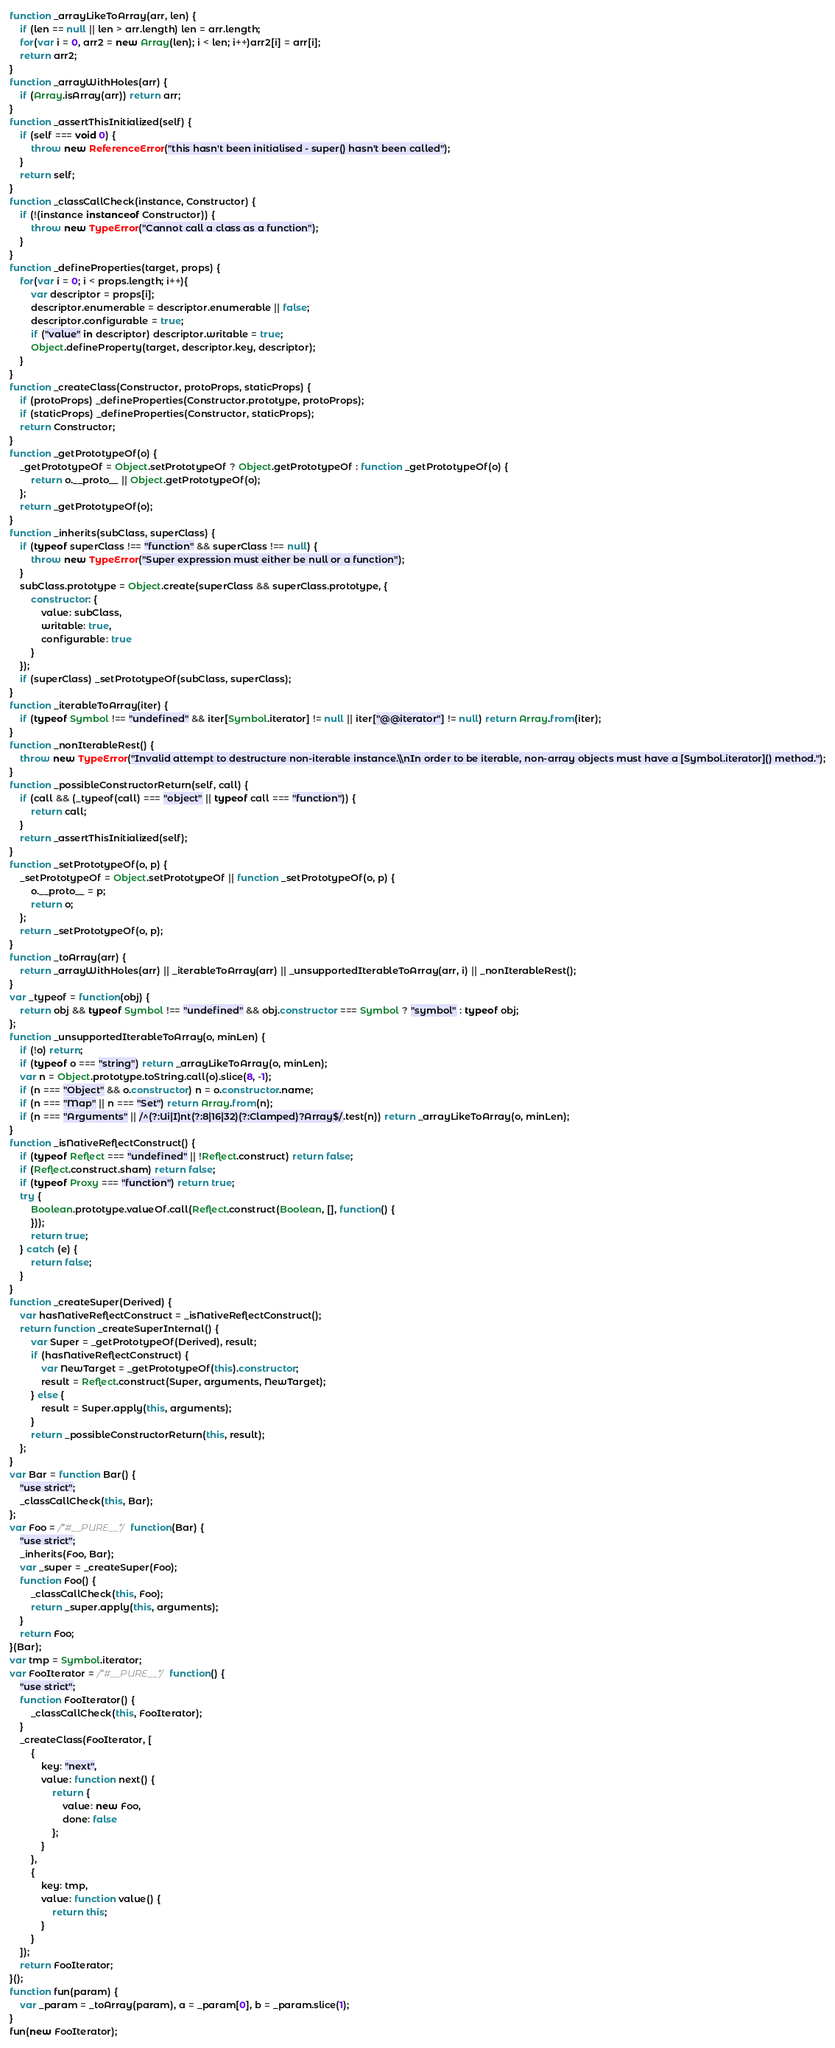Convert code to text. <code><loc_0><loc_0><loc_500><loc_500><_JavaScript_>function _arrayLikeToArray(arr, len) {
    if (len == null || len > arr.length) len = arr.length;
    for(var i = 0, arr2 = new Array(len); i < len; i++)arr2[i] = arr[i];
    return arr2;
}
function _arrayWithHoles(arr) {
    if (Array.isArray(arr)) return arr;
}
function _assertThisInitialized(self) {
    if (self === void 0) {
        throw new ReferenceError("this hasn't been initialised - super() hasn't been called");
    }
    return self;
}
function _classCallCheck(instance, Constructor) {
    if (!(instance instanceof Constructor)) {
        throw new TypeError("Cannot call a class as a function");
    }
}
function _defineProperties(target, props) {
    for(var i = 0; i < props.length; i++){
        var descriptor = props[i];
        descriptor.enumerable = descriptor.enumerable || false;
        descriptor.configurable = true;
        if ("value" in descriptor) descriptor.writable = true;
        Object.defineProperty(target, descriptor.key, descriptor);
    }
}
function _createClass(Constructor, protoProps, staticProps) {
    if (protoProps) _defineProperties(Constructor.prototype, protoProps);
    if (staticProps) _defineProperties(Constructor, staticProps);
    return Constructor;
}
function _getPrototypeOf(o) {
    _getPrototypeOf = Object.setPrototypeOf ? Object.getPrototypeOf : function _getPrototypeOf(o) {
        return o.__proto__ || Object.getPrototypeOf(o);
    };
    return _getPrototypeOf(o);
}
function _inherits(subClass, superClass) {
    if (typeof superClass !== "function" && superClass !== null) {
        throw new TypeError("Super expression must either be null or a function");
    }
    subClass.prototype = Object.create(superClass && superClass.prototype, {
        constructor: {
            value: subClass,
            writable: true,
            configurable: true
        }
    });
    if (superClass) _setPrototypeOf(subClass, superClass);
}
function _iterableToArray(iter) {
    if (typeof Symbol !== "undefined" && iter[Symbol.iterator] != null || iter["@@iterator"] != null) return Array.from(iter);
}
function _nonIterableRest() {
    throw new TypeError("Invalid attempt to destructure non-iterable instance.\\nIn order to be iterable, non-array objects must have a [Symbol.iterator]() method.");
}
function _possibleConstructorReturn(self, call) {
    if (call && (_typeof(call) === "object" || typeof call === "function")) {
        return call;
    }
    return _assertThisInitialized(self);
}
function _setPrototypeOf(o, p) {
    _setPrototypeOf = Object.setPrototypeOf || function _setPrototypeOf(o, p) {
        o.__proto__ = p;
        return o;
    };
    return _setPrototypeOf(o, p);
}
function _toArray(arr) {
    return _arrayWithHoles(arr) || _iterableToArray(arr) || _unsupportedIterableToArray(arr, i) || _nonIterableRest();
}
var _typeof = function(obj) {
    return obj && typeof Symbol !== "undefined" && obj.constructor === Symbol ? "symbol" : typeof obj;
};
function _unsupportedIterableToArray(o, minLen) {
    if (!o) return;
    if (typeof o === "string") return _arrayLikeToArray(o, minLen);
    var n = Object.prototype.toString.call(o).slice(8, -1);
    if (n === "Object" && o.constructor) n = o.constructor.name;
    if (n === "Map" || n === "Set") return Array.from(n);
    if (n === "Arguments" || /^(?:Ui|I)nt(?:8|16|32)(?:Clamped)?Array$/.test(n)) return _arrayLikeToArray(o, minLen);
}
function _isNativeReflectConstruct() {
    if (typeof Reflect === "undefined" || !Reflect.construct) return false;
    if (Reflect.construct.sham) return false;
    if (typeof Proxy === "function") return true;
    try {
        Boolean.prototype.valueOf.call(Reflect.construct(Boolean, [], function() {
        }));
        return true;
    } catch (e) {
        return false;
    }
}
function _createSuper(Derived) {
    var hasNativeReflectConstruct = _isNativeReflectConstruct();
    return function _createSuperInternal() {
        var Super = _getPrototypeOf(Derived), result;
        if (hasNativeReflectConstruct) {
            var NewTarget = _getPrototypeOf(this).constructor;
            result = Reflect.construct(Super, arguments, NewTarget);
        } else {
            result = Super.apply(this, arguments);
        }
        return _possibleConstructorReturn(this, result);
    };
}
var Bar = function Bar() {
    "use strict";
    _classCallCheck(this, Bar);
};
var Foo = /*#__PURE__*/ function(Bar) {
    "use strict";
    _inherits(Foo, Bar);
    var _super = _createSuper(Foo);
    function Foo() {
        _classCallCheck(this, Foo);
        return _super.apply(this, arguments);
    }
    return Foo;
}(Bar);
var tmp = Symbol.iterator;
var FooIterator = /*#__PURE__*/ function() {
    "use strict";
    function FooIterator() {
        _classCallCheck(this, FooIterator);
    }
    _createClass(FooIterator, [
        {
            key: "next",
            value: function next() {
                return {
                    value: new Foo,
                    done: false
                };
            }
        },
        {
            key: tmp,
            value: function value() {
                return this;
            }
        }
    ]);
    return FooIterator;
}();
function fun(param) {
    var _param = _toArray(param), a = _param[0], b = _param.slice(1);
}
fun(new FooIterator);
</code> 